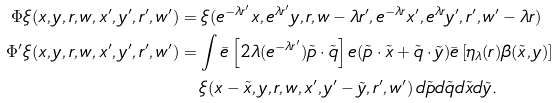<formula> <loc_0><loc_0><loc_500><loc_500>\Phi \xi ( x , y , r , w , x ^ { \prime } , y ^ { \prime } , r ^ { \prime } , w ^ { \prime } ) & = \xi ( e ^ { - \lambda r ^ { \prime } } x , e ^ { \lambda r ^ { \prime } } y , r , w - \lambda r ^ { \prime } , e ^ { - \lambda r } x ^ { \prime } , e ^ { \lambda r } y ^ { \prime } , r ^ { \prime } , w ^ { \prime } - \lambda r ) \\ \Phi ^ { \prime } \xi ( x , y , r , w , x ^ { \prime } , y ^ { \prime } , r ^ { \prime } , w ^ { \prime } ) & = \int \bar { e } \left [ 2 \lambda ( e ^ { - \lambda r ^ { \prime } } ) \tilde { p } \cdot \tilde { q } \right ] e ( \tilde { p } \cdot \tilde { x } + \tilde { q } \cdot \tilde { y } ) \bar { e } \left [ \eta _ { \lambda } ( r ) \beta ( \tilde { x } , y ) \right ] \\ & \quad \xi ( x - \tilde { x } , y , r , w , x ^ { \prime } , y ^ { \prime } - \tilde { y } , r ^ { \prime } , w ^ { \prime } ) \, d \tilde { p } d \tilde { q } d \tilde { x } d \tilde { y } .</formula> 